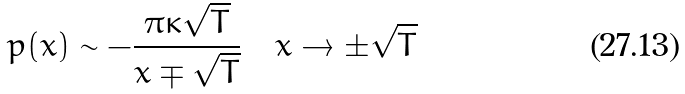<formula> <loc_0><loc_0><loc_500><loc_500>p ( x ) \sim - \frac { \pi \kappa \sqrt { T } } { x \mp \sqrt { T } } \quad x \to \pm \sqrt { T }</formula> 